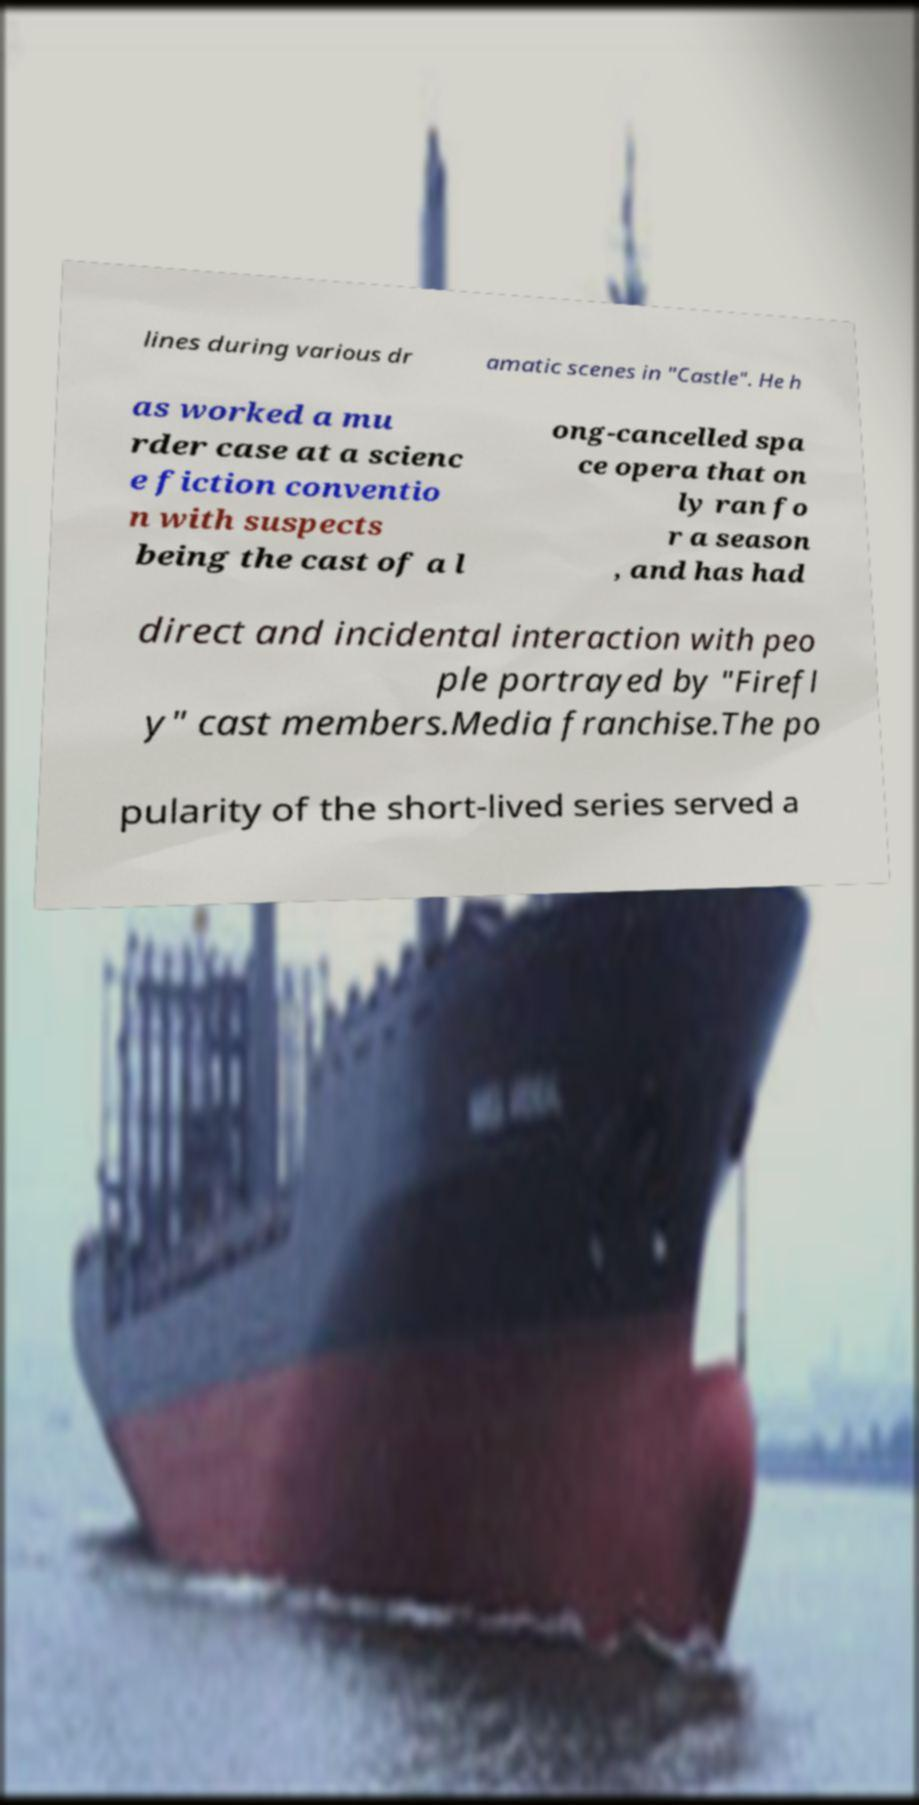For documentation purposes, I need the text within this image transcribed. Could you provide that? lines during various dr amatic scenes in "Castle". He h as worked a mu rder case at a scienc e fiction conventio n with suspects being the cast of a l ong-cancelled spa ce opera that on ly ran fo r a season , and has had direct and incidental interaction with peo ple portrayed by "Firefl y" cast members.Media franchise.The po pularity of the short-lived series served a 